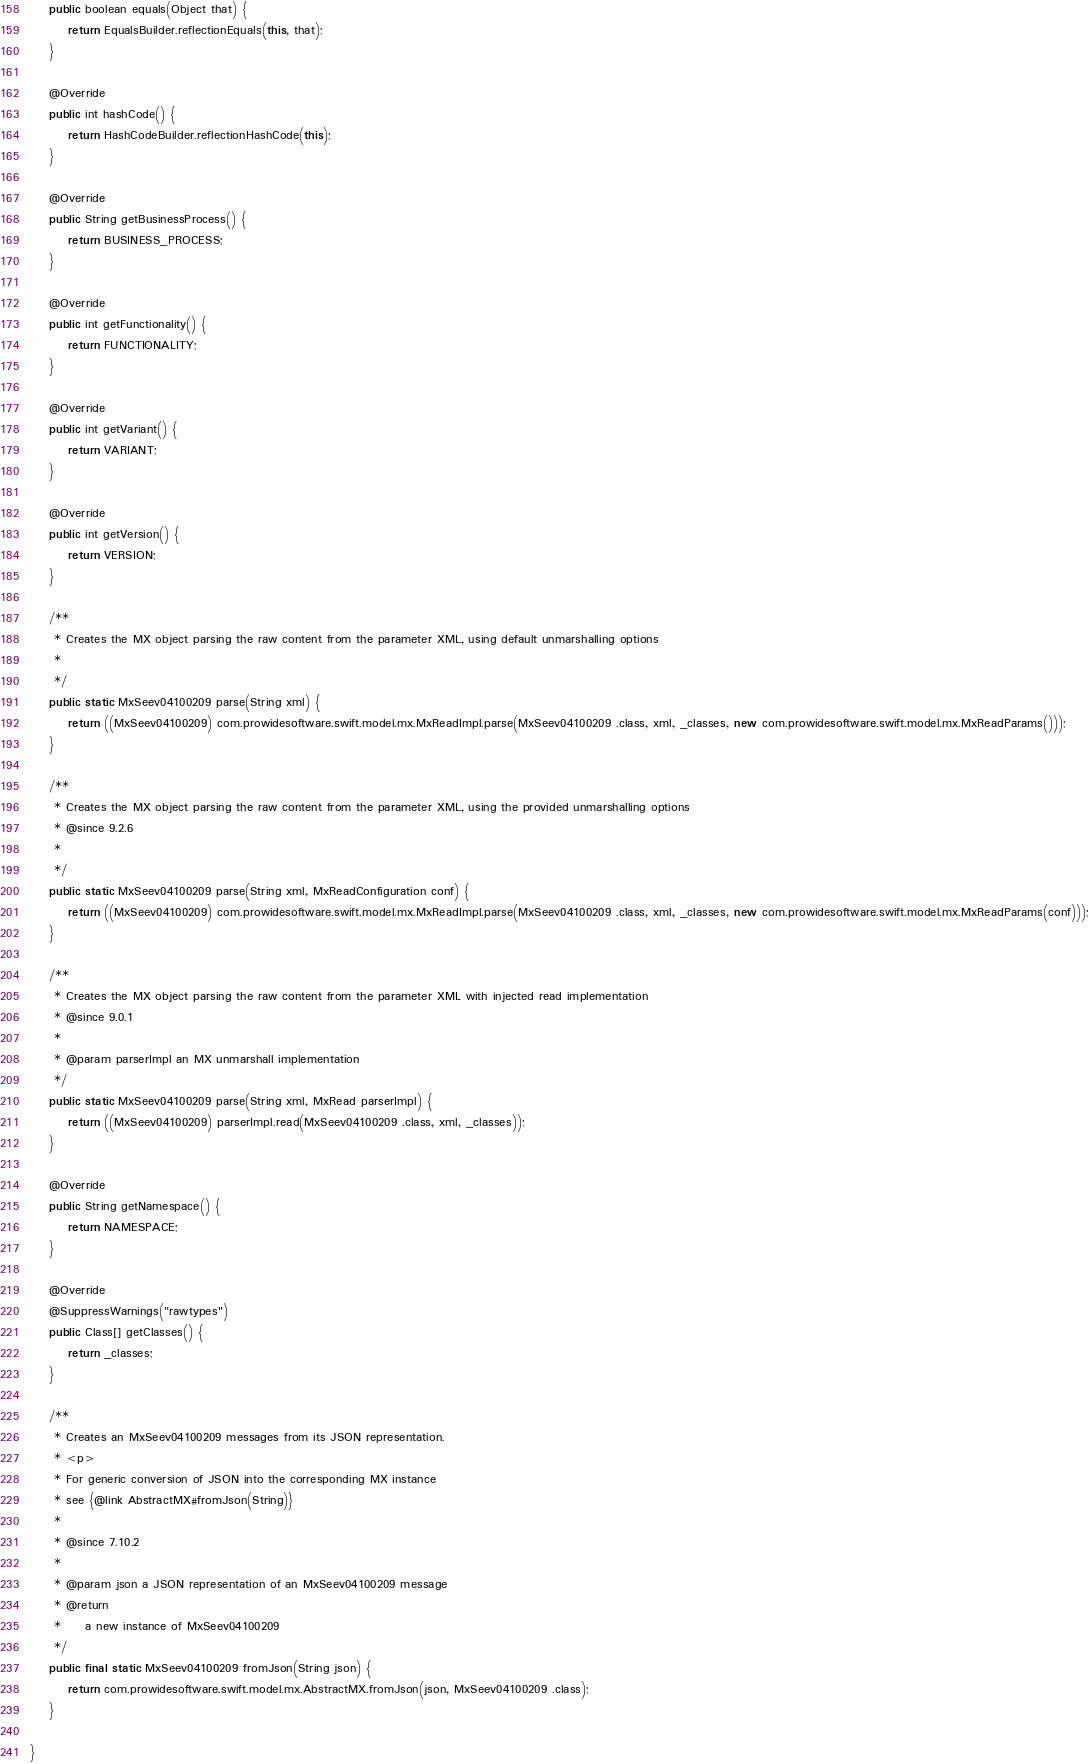<code> <loc_0><loc_0><loc_500><loc_500><_Java_>    public boolean equals(Object that) {
        return EqualsBuilder.reflectionEquals(this, that);
    }

    @Override
    public int hashCode() {
        return HashCodeBuilder.reflectionHashCode(this);
    }

    @Override
    public String getBusinessProcess() {
        return BUSINESS_PROCESS;
    }

    @Override
    public int getFunctionality() {
        return FUNCTIONALITY;
    }

    @Override
    public int getVariant() {
        return VARIANT;
    }

    @Override
    public int getVersion() {
        return VERSION;
    }

    /**
     * Creates the MX object parsing the raw content from the parameter XML, using default unmarshalling options
     * 
     */
    public static MxSeev04100209 parse(String xml) {
        return ((MxSeev04100209) com.prowidesoftware.swift.model.mx.MxReadImpl.parse(MxSeev04100209 .class, xml, _classes, new com.prowidesoftware.swift.model.mx.MxReadParams()));
    }

    /**
     * Creates the MX object parsing the raw content from the parameter XML, using the provided unmarshalling options
     * @since 9.2.6
     * 
     */
    public static MxSeev04100209 parse(String xml, MxReadConfiguration conf) {
        return ((MxSeev04100209) com.prowidesoftware.swift.model.mx.MxReadImpl.parse(MxSeev04100209 .class, xml, _classes, new com.prowidesoftware.swift.model.mx.MxReadParams(conf)));
    }

    /**
     * Creates the MX object parsing the raw content from the parameter XML with injected read implementation
     * @since 9.0.1
     * 
     * @param parserImpl an MX unmarshall implementation
     */
    public static MxSeev04100209 parse(String xml, MxRead parserImpl) {
        return ((MxSeev04100209) parserImpl.read(MxSeev04100209 .class, xml, _classes));
    }

    @Override
    public String getNamespace() {
        return NAMESPACE;
    }

    @Override
    @SuppressWarnings("rawtypes")
    public Class[] getClasses() {
        return _classes;
    }

    /**
     * Creates an MxSeev04100209 messages from its JSON representation.
     * <p>
     * For generic conversion of JSON into the corresponding MX instance 
     * see {@link AbstractMX#fromJson(String)}
     * 
     * @since 7.10.2
     * 
     * @param json a JSON representation of an MxSeev04100209 message
     * @return
     *     a new instance of MxSeev04100209
     */
    public final static MxSeev04100209 fromJson(String json) {
        return com.prowidesoftware.swift.model.mx.AbstractMX.fromJson(json, MxSeev04100209 .class);
    }

}
</code> 